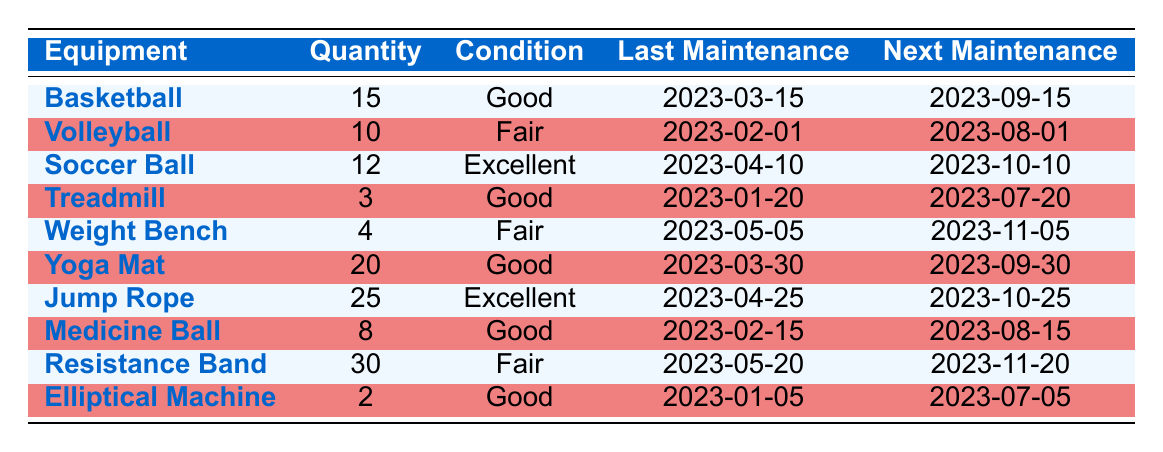How many basketballs does the school have? The table shows that the quantity of basketballs is listed directly under the Quantity column in the row corresponding to Basketball. The value is 15.
Answer: 15 What is the condition of the volleyball equipment? The condition of the volleyball equipment can be found in the corresponding row under the Condition column where Volleyball is listed. The value is Fair.
Answer: Fair When was the last maintenance performed on the treadmill? To find the last maintenance date for the treadmill, look in the Last Maintenance column for the row marked as Treadmill. The date listed is 2023-01-20.
Answer: 2023-01-20 How many total pieces of equipment are in good condition? To find the total number of equipment in good condition, count the rows where the Condition is Good. This includes Basketball, Treadmill, Yoga Mat, Jump Rope, and Elliptical Machine, which totals to 5.
Answer: 5 Is there any equipment in excellent condition? By looking through the Condition column, we can see that Soccer Ball and Jump Rope are marked as Excellent. Since both are present, the answer is yes.
Answer: Yes What is the next maintenance date for the weight bench? The next maintenance date for the weight bench can be found under the Next Maintenance column in the row for Weight Bench. The date is 2023-11-05.
Answer: 2023-11-05 Which equipment has the highest quantity and what is that quantity? To find the equipment with the highest quantity, compare all the values in the Quantity column. The maximum value is 30 for the Resistance Band.
Answer: Resistance Band, 30 How many more yoga mats are there than treadmills? To find out how many more yoga mats there are than treadmills, subtract the quantity of treadmills (3) from the quantity of yoga mats (20). 20 - 3 equals 17.
Answer: 17 Which equipment requires maintenance next in August 2023? Check the Next Maintenance column for entries scheduled for August 2023. Volleyball has a next maintenance date of 2023-08-01, and Medicine Ball has 2023-08-15. So, Volleyball requires maintenance first.
Answer: Volleyball 